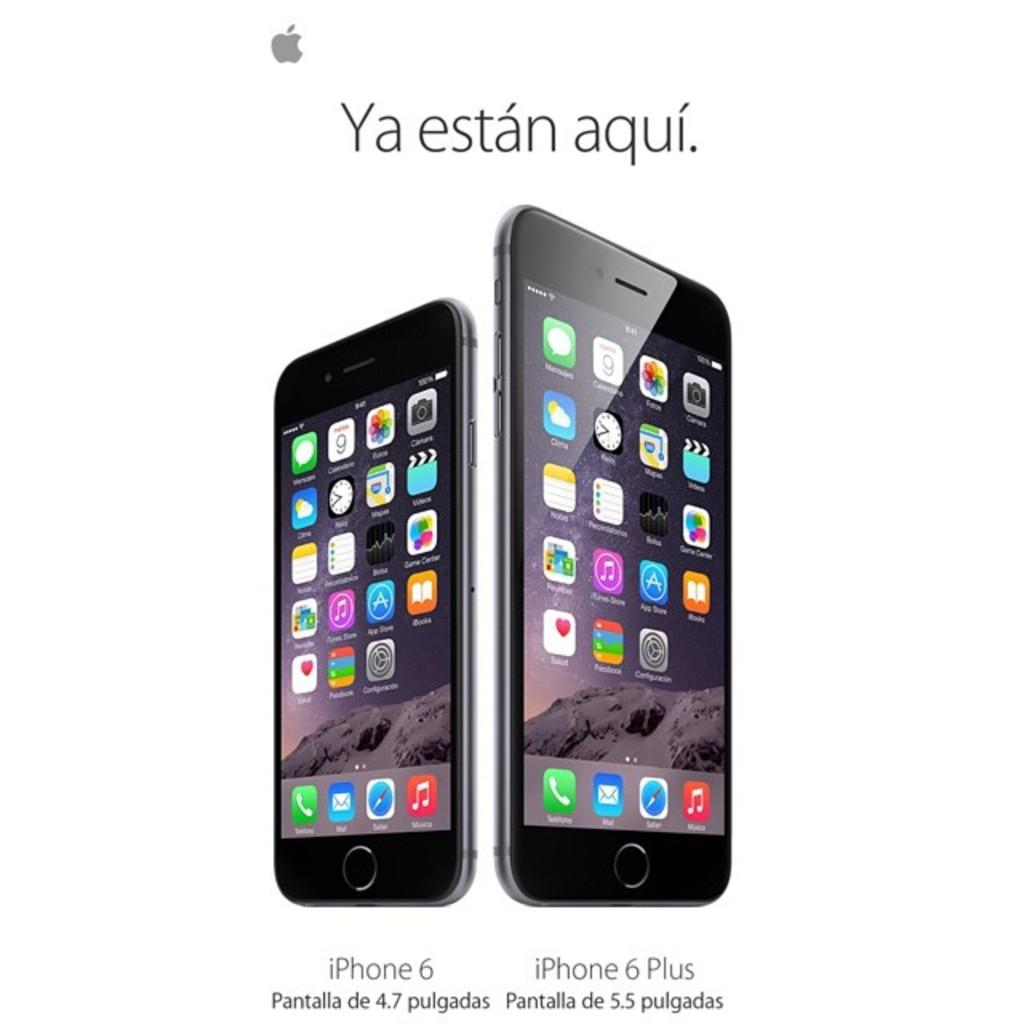<image>
Provide a brief description of the given image. a phone that has iPhone written at the bottom 